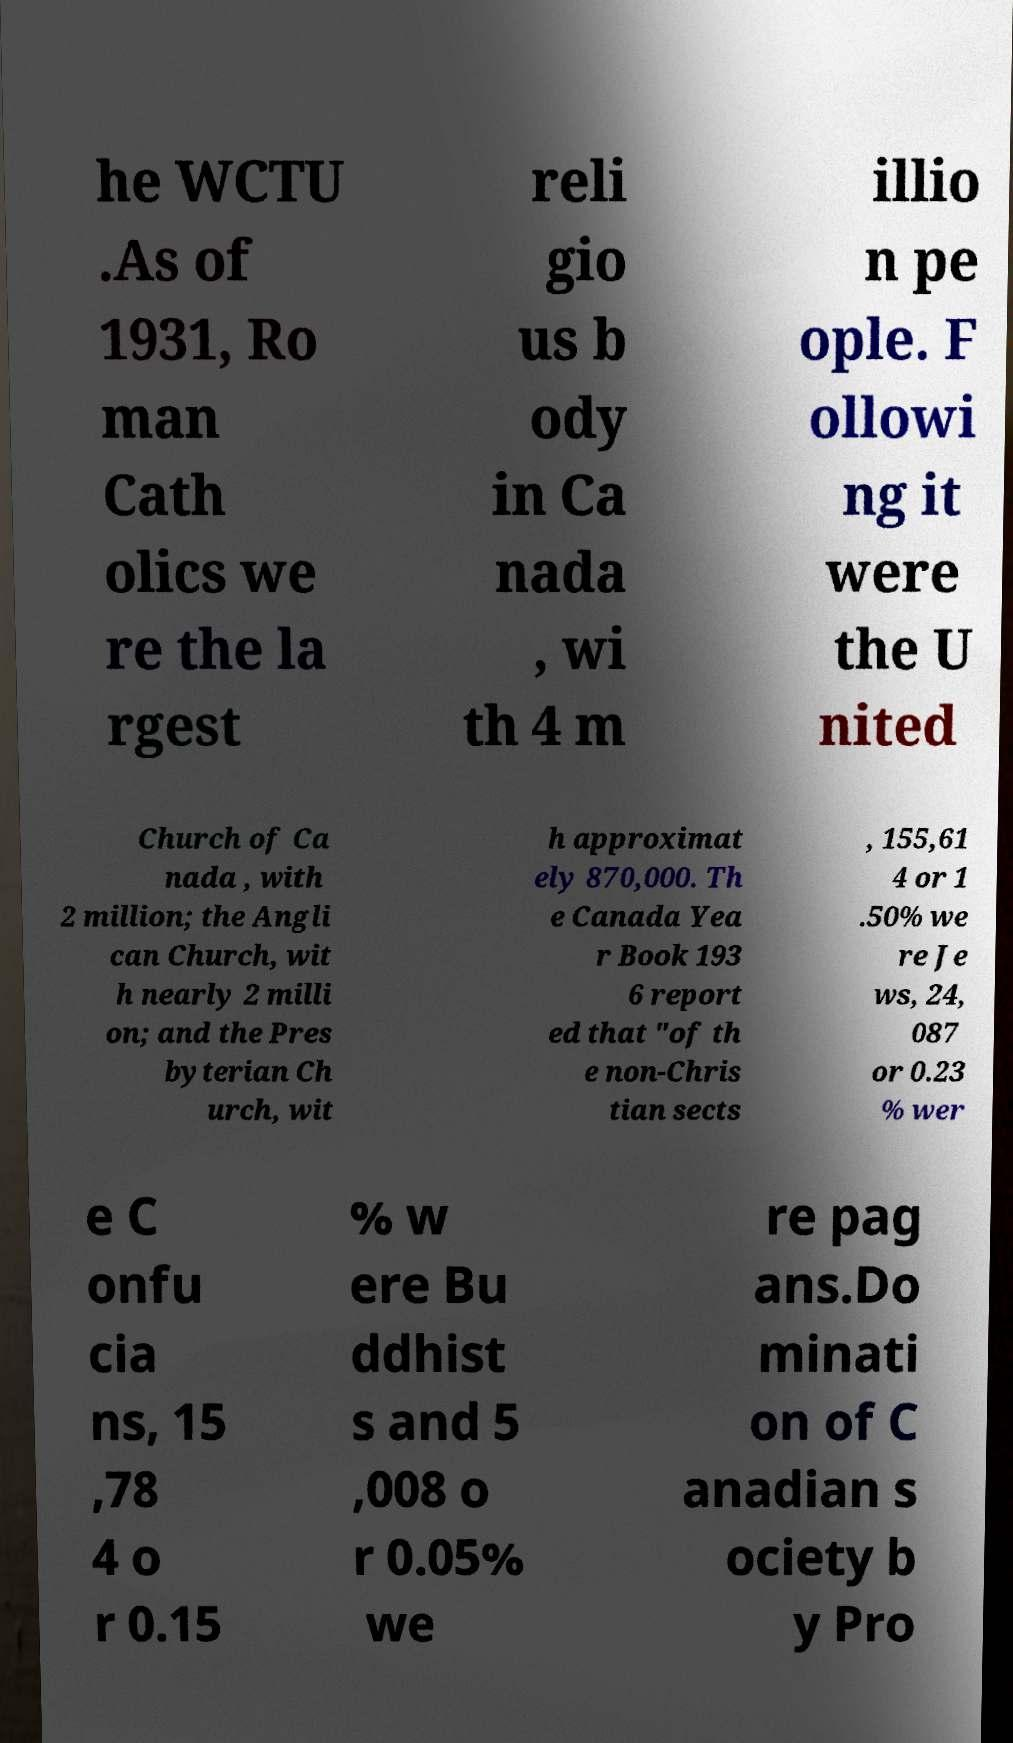For documentation purposes, I need the text within this image transcribed. Could you provide that? he WCTU .As of 1931, Ro man Cath olics we re the la rgest reli gio us b ody in Ca nada , wi th 4 m illio n pe ople. F ollowi ng it were the U nited Church of Ca nada , with 2 million; the Angli can Church, wit h nearly 2 milli on; and the Pres byterian Ch urch, wit h approximat ely 870,000. Th e Canada Yea r Book 193 6 report ed that "of th e non-Chris tian sects , 155,61 4 or 1 .50% we re Je ws, 24, 087 or 0.23 % wer e C onfu cia ns, 15 ,78 4 o r 0.15 % w ere Bu ddhist s and 5 ,008 o r 0.05% we re pag ans.Do minati on of C anadian s ociety b y Pro 